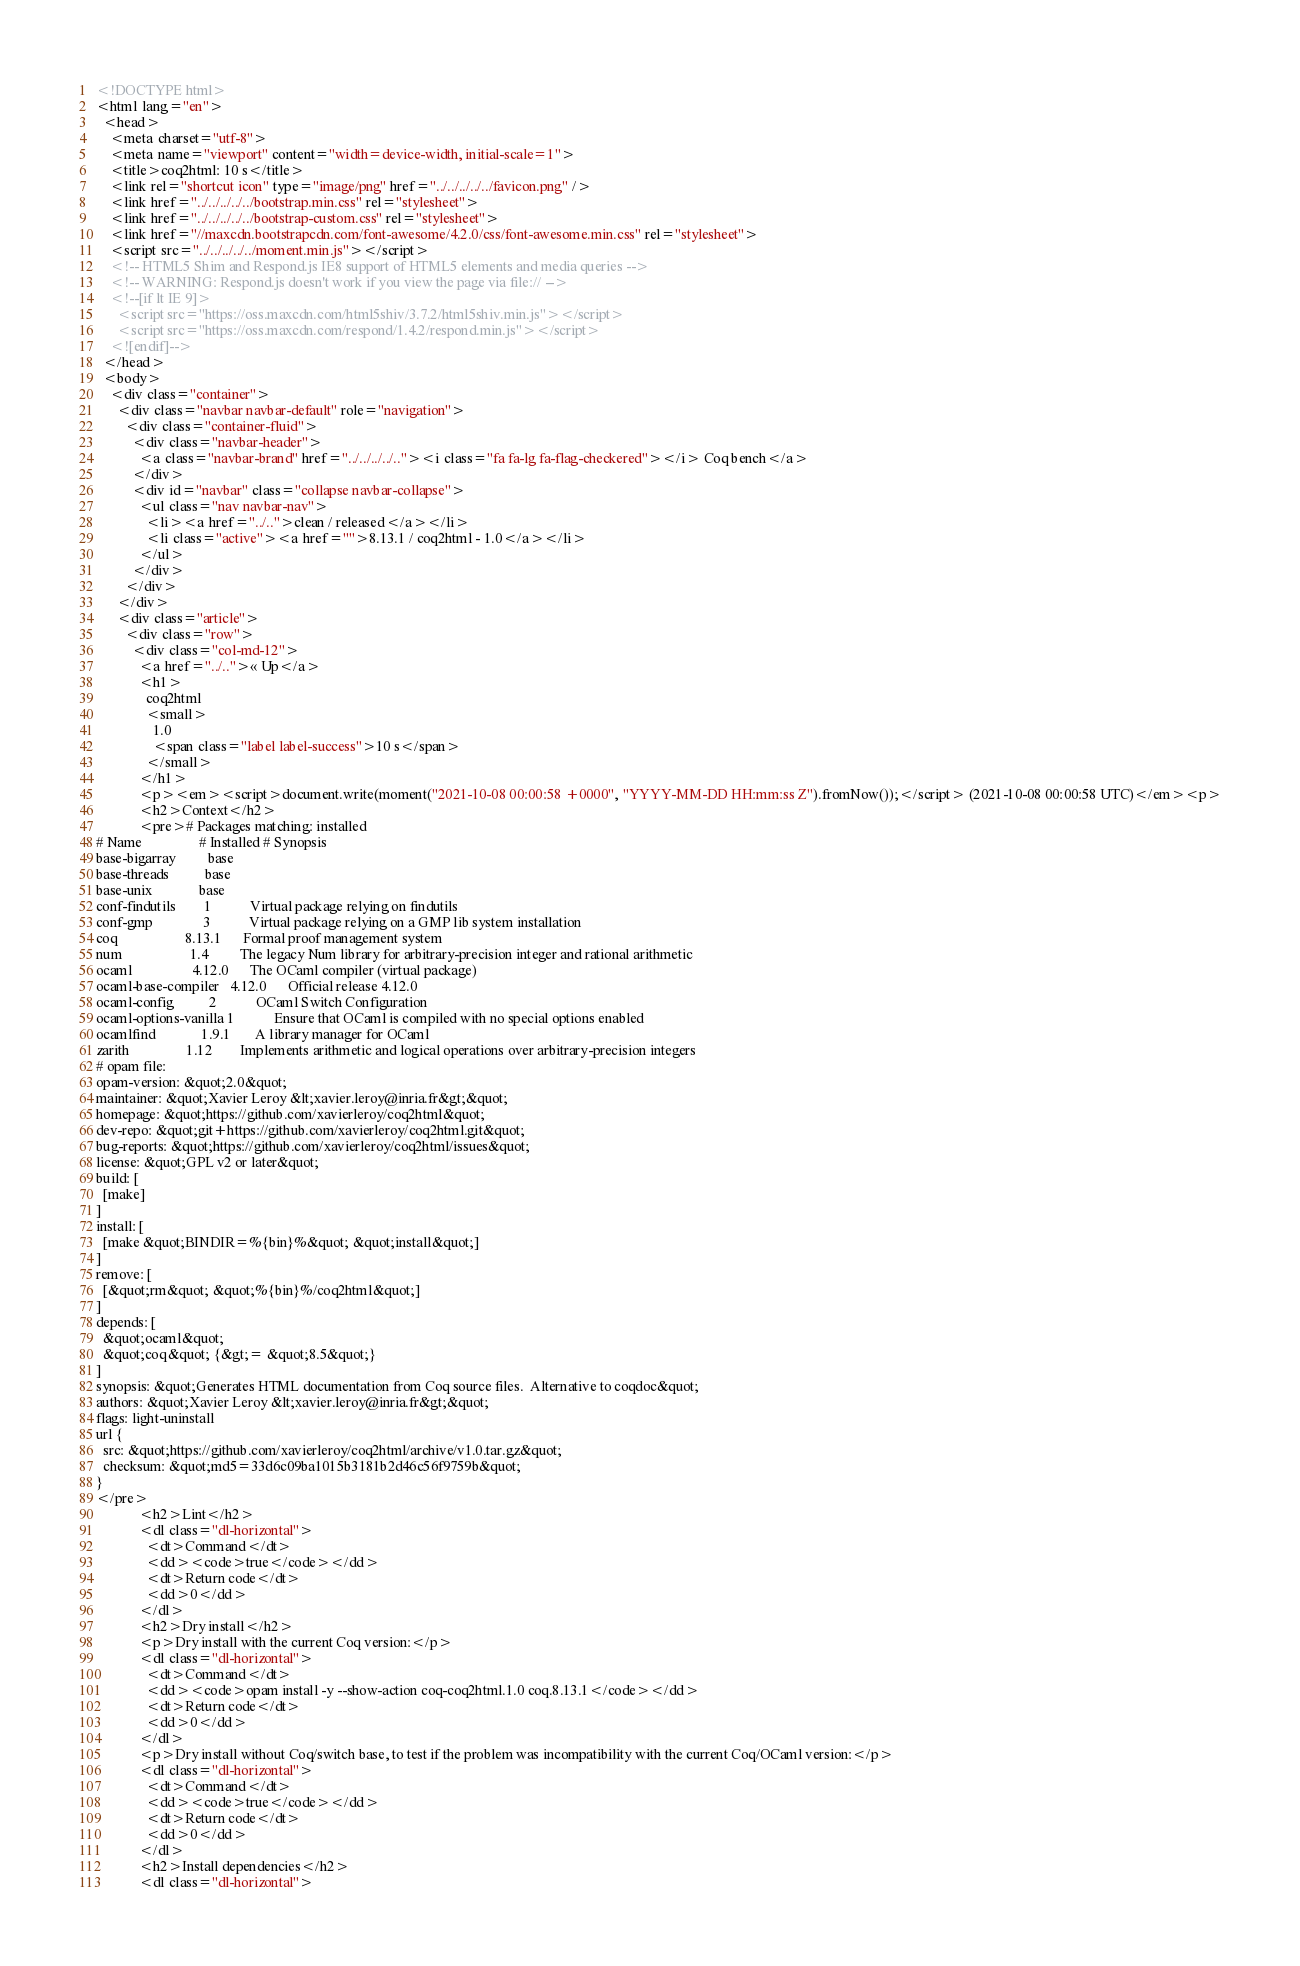Convert code to text. <code><loc_0><loc_0><loc_500><loc_500><_HTML_><!DOCTYPE html>
<html lang="en">
  <head>
    <meta charset="utf-8">
    <meta name="viewport" content="width=device-width, initial-scale=1">
    <title>coq2html: 10 s</title>
    <link rel="shortcut icon" type="image/png" href="../../../../../favicon.png" />
    <link href="../../../../../bootstrap.min.css" rel="stylesheet">
    <link href="../../../../../bootstrap-custom.css" rel="stylesheet">
    <link href="//maxcdn.bootstrapcdn.com/font-awesome/4.2.0/css/font-awesome.min.css" rel="stylesheet">
    <script src="../../../../../moment.min.js"></script>
    <!-- HTML5 Shim and Respond.js IE8 support of HTML5 elements and media queries -->
    <!-- WARNING: Respond.js doesn't work if you view the page via file:// -->
    <!--[if lt IE 9]>
      <script src="https://oss.maxcdn.com/html5shiv/3.7.2/html5shiv.min.js"></script>
      <script src="https://oss.maxcdn.com/respond/1.4.2/respond.min.js"></script>
    <![endif]-->
  </head>
  <body>
    <div class="container">
      <div class="navbar navbar-default" role="navigation">
        <div class="container-fluid">
          <div class="navbar-header">
            <a class="navbar-brand" href="../../../../.."><i class="fa fa-lg fa-flag-checkered"></i> Coq bench</a>
          </div>
          <div id="navbar" class="collapse navbar-collapse">
            <ul class="nav navbar-nav">
              <li><a href="../..">clean / released</a></li>
              <li class="active"><a href="">8.13.1 / coq2html - 1.0</a></li>
            </ul>
          </div>
        </div>
      </div>
      <div class="article">
        <div class="row">
          <div class="col-md-12">
            <a href="../..">« Up</a>
            <h1>
              coq2html
              <small>
                1.0
                <span class="label label-success">10 s</span>
              </small>
            </h1>
            <p><em><script>document.write(moment("2021-10-08 00:00:58 +0000", "YYYY-MM-DD HH:mm:ss Z").fromNow());</script> (2021-10-08 00:00:58 UTC)</em><p>
            <h2>Context</h2>
            <pre># Packages matching: installed
# Name                # Installed # Synopsis
base-bigarray         base
base-threads          base
base-unix             base
conf-findutils        1           Virtual package relying on findutils
conf-gmp              3           Virtual package relying on a GMP lib system installation
coq                   8.13.1      Formal proof management system
num                   1.4         The legacy Num library for arbitrary-precision integer and rational arithmetic
ocaml                 4.12.0      The OCaml compiler (virtual package)
ocaml-base-compiler   4.12.0      Official release 4.12.0
ocaml-config          2           OCaml Switch Configuration
ocaml-options-vanilla 1           Ensure that OCaml is compiled with no special options enabled
ocamlfind             1.9.1       A library manager for OCaml
zarith                1.12        Implements arithmetic and logical operations over arbitrary-precision integers
# opam file:
opam-version: &quot;2.0&quot;
maintainer: &quot;Xavier Leroy &lt;xavier.leroy@inria.fr&gt;&quot;
homepage: &quot;https://github.com/xavierleroy/coq2html&quot;
dev-repo: &quot;git+https://github.com/xavierleroy/coq2html.git&quot;
bug-reports: &quot;https://github.com/xavierleroy/coq2html/issues&quot;
license: &quot;GPL v2 or later&quot;
build: [
  [make]
]
install: [
  [make &quot;BINDIR=%{bin}%&quot; &quot;install&quot;]
]
remove: [
  [&quot;rm&quot; &quot;%{bin}%/coq2html&quot;]
]
depends: [
  &quot;ocaml&quot;
  &quot;coq&quot; {&gt;= &quot;8.5&quot;}
]
synopsis: &quot;Generates HTML documentation from Coq source files.  Alternative to coqdoc&quot;
authors: &quot;Xavier Leroy &lt;xavier.leroy@inria.fr&gt;&quot;
flags: light-uninstall
url {
  src: &quot;https://github.com/xavierleroy/coq2html/archive/v1.0.tar.gz&quot;
  checksum: &quot;md5=33d6c09ba1015b3181b2d46c56f9759b&quot;
}
</pre>
            <h2>Lint</h2>
            <dl class="dl-horizontal">
              <dt>Command</dt>
              <dd><code>true</code></dd>
              <dt>Return code</dt>
              <dd>0</dd>
            </dl>
            <h2>Dry install</h2>
            <p>Dry install with the current Coq version:</p>
            <dl class="dl-horizontal">
              <dt>Command</dt>
              <dd><code>opam install -y --show-action coq-coq2html.1.0 coq.8.13.1</code></dd>
              <dt>Return code</dt>
              <dd>0</dd>
            </dl>
            <p>Dry install without Coq/switch base, to test if the problem was incompatibility with the current Coq/OCaml version:</p>
            <dl class="dl-horizontal">
              <dt>Command</dt>
              <dd><code>true</code></dd>
              <dt>Return code</dt>
              <dd>0</dd>
            </dl>
            <h2>Install dependencies</h2>
            <dl class="dl-horizontal"></code> 